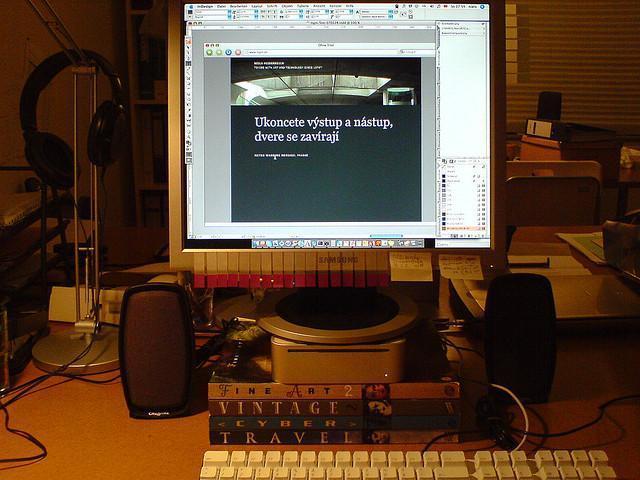How many cars are in the image?
Give a very brief answer. 0. How many books are in the picture?
Give a very brief answer. 2. How many people in the image are wearing bright green jackets?
Give a very brief answer. 0. 